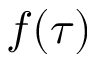<formula> <loc_0><loc_0><loc_500><loc_500>f ( \tau )</formula> 